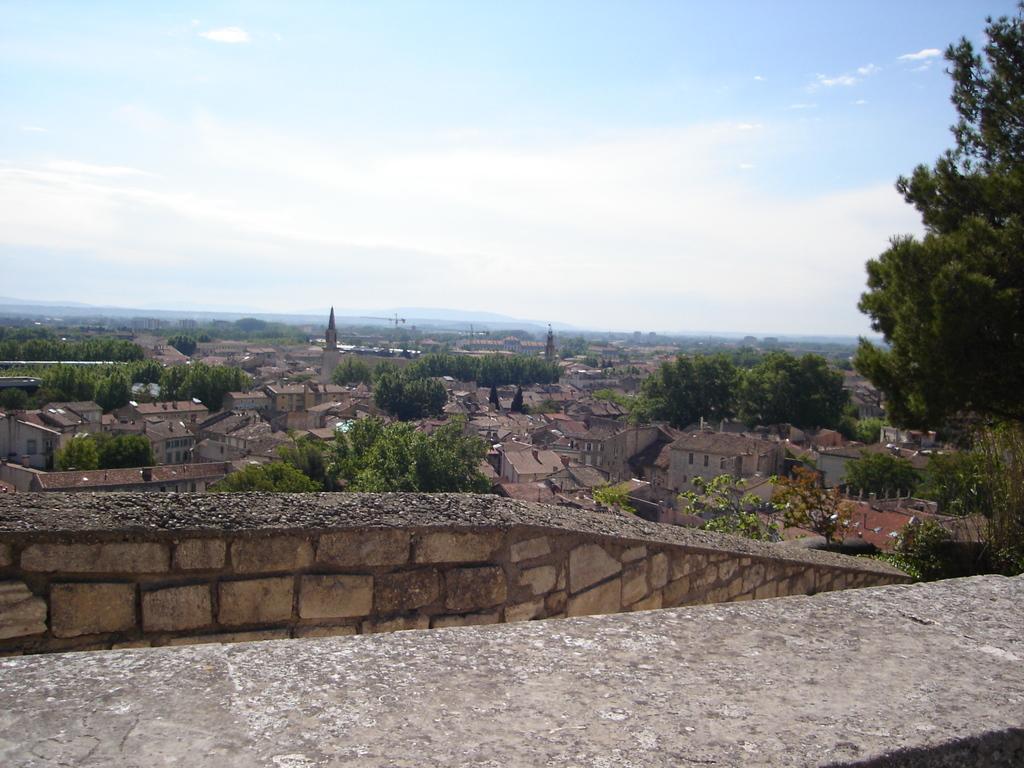Please provide a concise description of this image. In the center of the image there is a wall and slab. In the background, we can see the sky, clouds, buildings, windows, trees and a few other objects. 